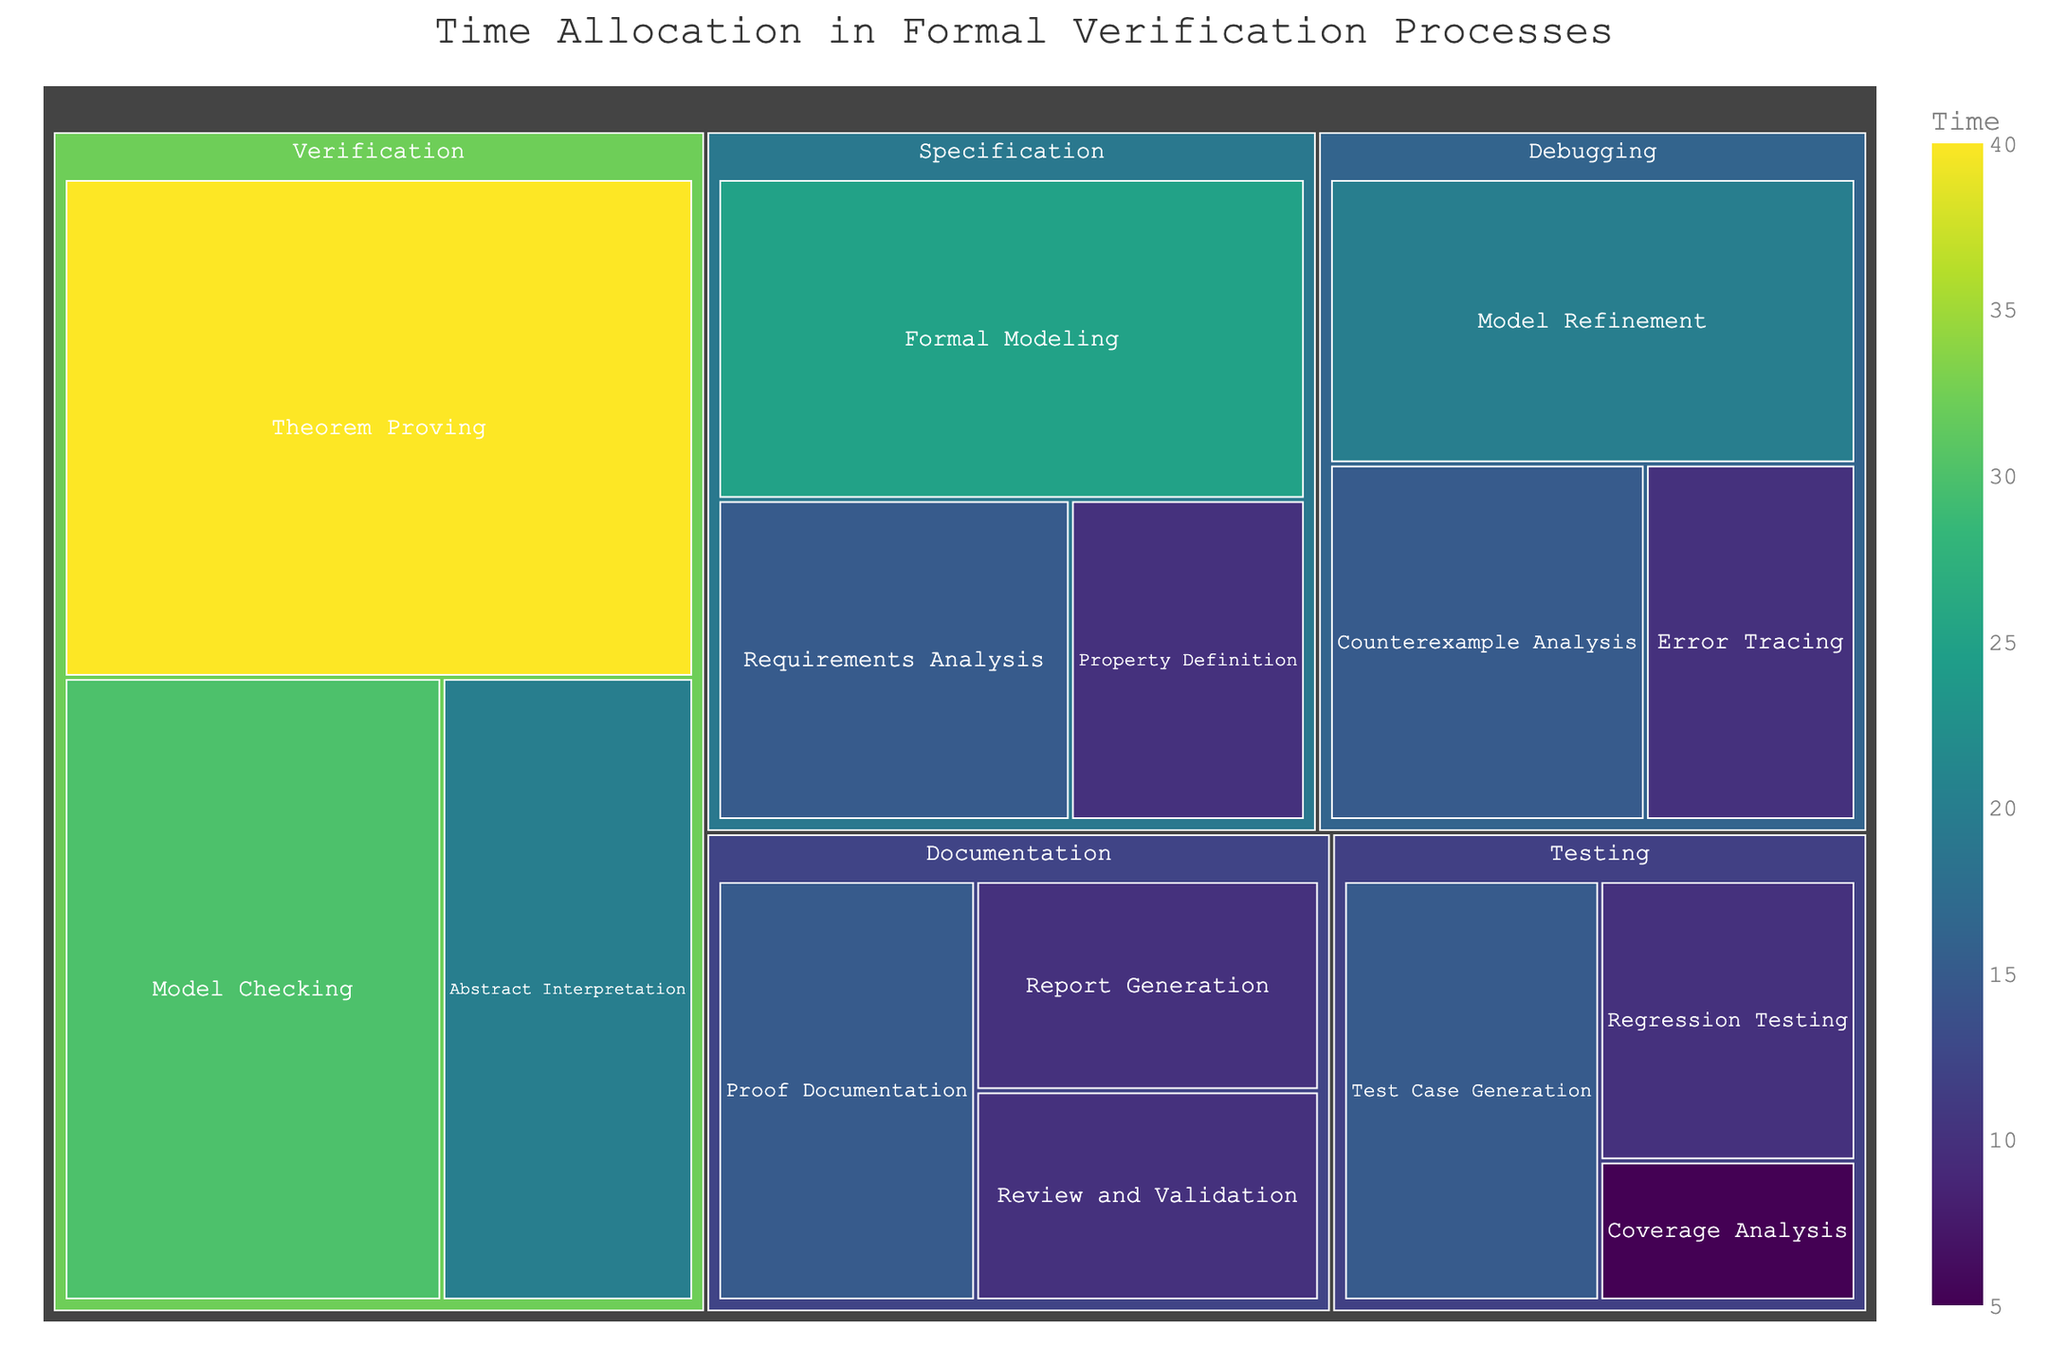What's the title of the figure? The title of the figure is usually displayed prominently at the top of the chart. In this case, it reads "Time Allocation in Formal Verification Processes."
Answer: Time Allocation in Formal Verification Processes Which subcategory has the highest allocated time? By observing the treemap, the subcategory with the largest area and darkest color typically indicates the highest time allocation. The "Theorem Proving" subcategory under the "Verification" category stands out the most with 40 hours.
Answer: Theorem Proving What is the total time allocated to the Specification category? Sum the time spent in each subcategory under Specification: 15 (Requirements Analysis) + 25 (Formal Modeling) + 10 (Property Definition). The total is 50 hours.
Answer: 50 hours How does the time spent on Error Tracing compare to Test Case Generation? Locate both subcategories on the treemap. Error Tracing has 10 hours, while Test Case Generation has 15 hours. Therefore, Test Case Generation has more time allocated.
Answer: Test Case Generation (15 hours) > Error Tracing (10 hours) What is the average time allocated to subcategories within the Debugging category? Sum the time for all Debugging subcategories [15 (Counterexample Analysis) + 10 (Error Tracing) + 20 (Model Refinement) = 45 hours], then divide by the number of subcategories (3). The average time is 45/3.
Answer: 15 hours Which category has the least total time allocated? By summing the time for each main category and comparing, the total time is: Specification (50), Verification (90), Debugging (45), Testing (30), Documentation (35). Testing has the least total time.
Answer: Testing How much time is allocated to Verification compared to Testing? Total time for Verification is 90 hours (sum of all subcategories) and for Testing is 30 hours. Verification has more time allocated.
Answer: Verification (90 hours) > Testing (30 hours) Identify the second largest subcategory under Verification in terms of time allocation. Locate the three subcategories under Verification and observe the areas and values. Model Checking has 30 hours, Theorem Proving 40 hours, Abstract Interpretation 20 hours. The second largest is Model Checking.
Answer: Model Checking What is the total time allocated to all categories combined? Sum the total time for all categories: Specification (50) + Verification (90) + Debugging (45) + Testing (30) + Documentation (35). The total is 250 hours.
Answer: 250 hours Which subcategory spends equal time on Debugging's Counterexample Analysis and Specification's Requirements Analysis? Both Counterexample Analysis under Debugging and Requirements Analysis under Specification have 15 hours each.
Answer: Counterexample Analysis and Requirements Analysis 